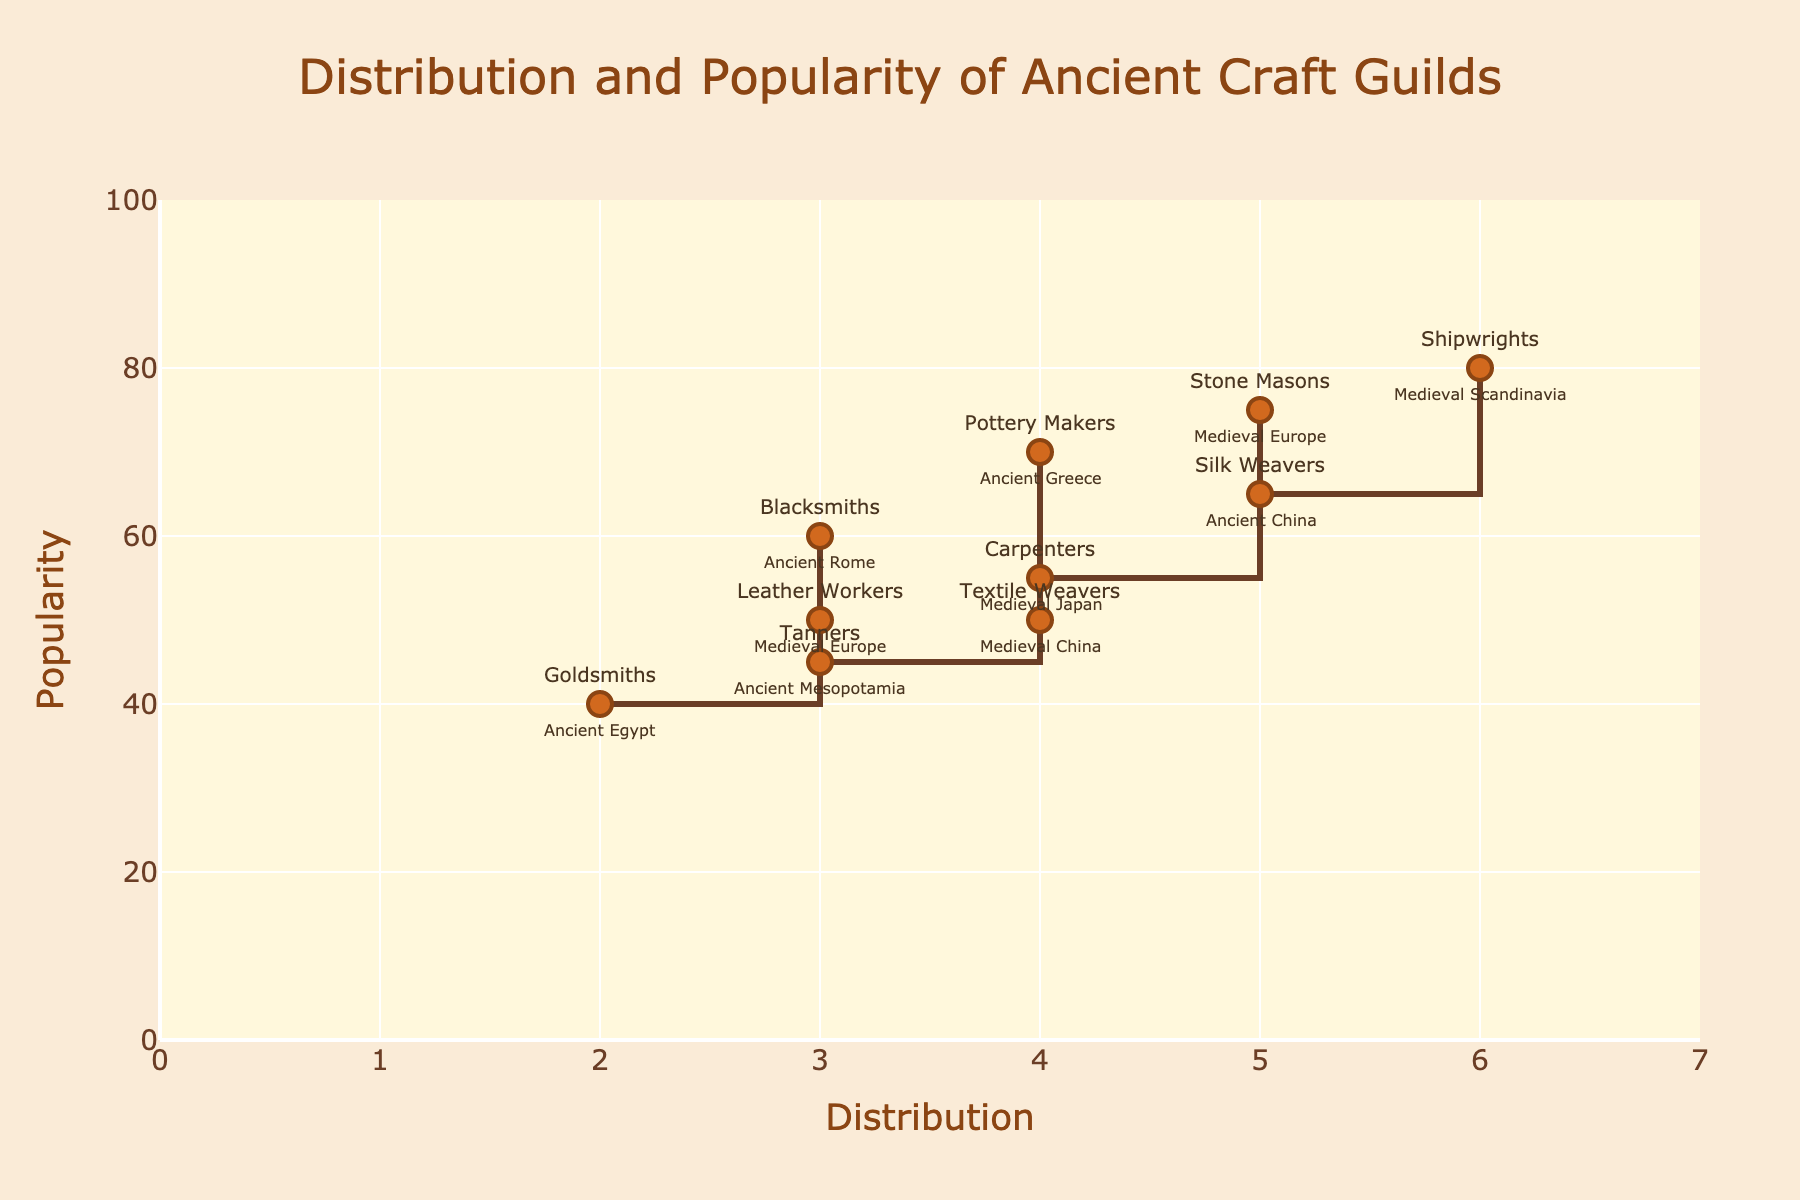What is the title of the figure? The title is typically located at the top center of the figure, where it is clearly indicated.
Answer: Distribution and Popularity of Ancient Craft Guilds Which ancient craft guild has the highest distribution? By examining the horizontal axis labeled 'Distribution,' identify the data point at the uppermost position.
Answer: Shipwrights Which ancient craft guild has the lowest popularity? Look for the data point that is positioned closest to the bottom on the 'Popularity' axis.
Answer: Tanners Which historic period corresponds to the ancient craft guild with a distribution of 5? Look at the annotations placed around the data points along the 'Distribution' value of 5.
Answer: Medieval Europe Compare the popularity of Stone Masons and Blacksmiths. Which one is more popular? Identify the 'Popularity' values for both Stone Masons and Blacksmiths and compare them.
Answer: Stone Masons What is the average popularity of the craft guilds with a distribution of 4? Identify the popularity values for 'Textile Weavers,' 'Pottery Makers,' and 'Carpenters,' then calculate the average: (50+70+55)/3.
Answer: 58.33 Which craft guild serving Ancient Rome is included in the plot, and what is its role in the economy? Locate the data point label for the guild related to Ancient Rome and read the accompanying text.
Answer: Blacksmiths, Weapons and tools production Compare the popularity of craft guilds in Medieval China and Ancient China. Which period has the higher average popularity? Identify the data points for Medieval China (Textile Weavers) and Ancient China (Silk Weavers), and then calculate the average popularity values: (50) and (65), respectively.
Answer: Ancient China Which ancient craft guilds have a distribution value of 3, and how do their popularity values compare? Identify all data points with a distribution of 3 and compare their popularity values by examining their vertical positions.
Answer: Blacksmiths, Leather Workers, Tanners What role did Pottery Makers play in the economy of Ancient Greece? Find the label for Pottery Makers and read the associated information regarding their role in the economy.
Answer: Household goods and trade 